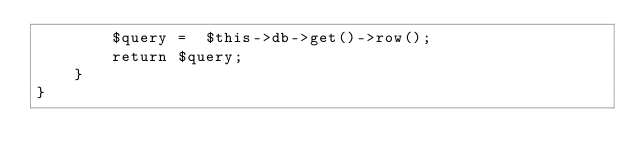<code> <loc_0><loc_0><loc_500><loc_500><_PHP_>		$query =  $this->db->get()->row();
		return $query;
	}
}</code> 